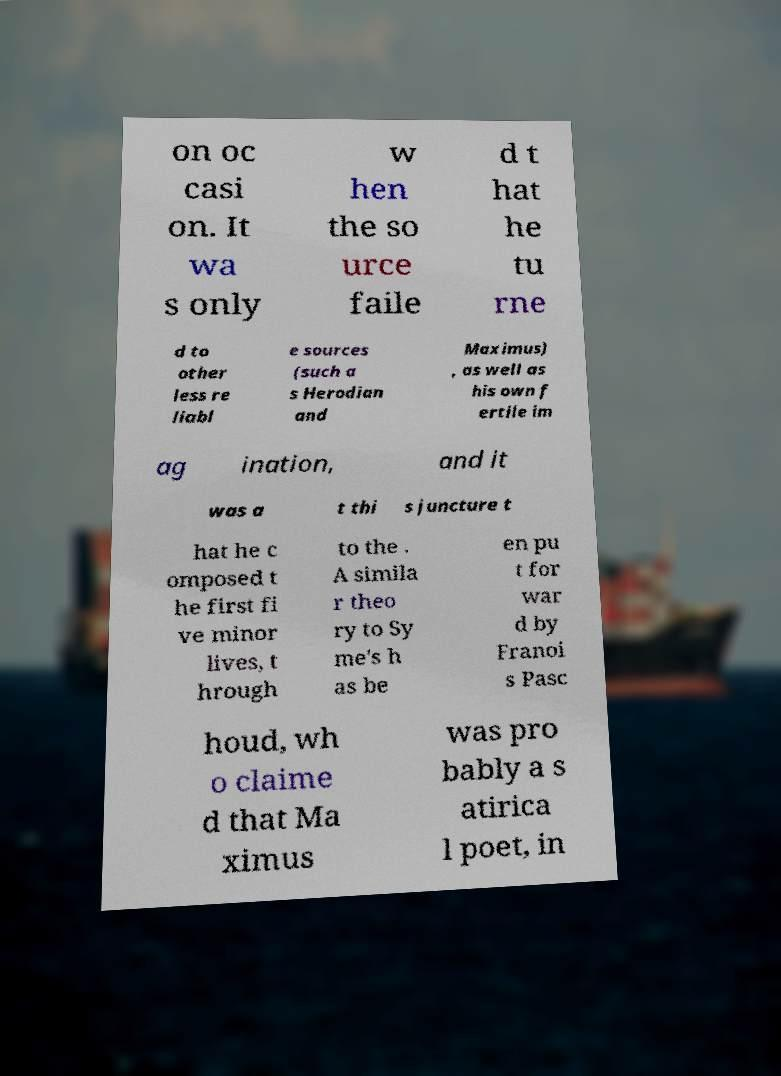Please identify and transcribe the text found in this image. on oc casi on. It wa s only w hen the so urce faile d t hat he tu rne d to other less re liabl e sources (such a s Herodian and Maximus) , as well as his own f ertile im ag ination, and it was a t thi s juncture t hat he c omposed t he first fi ve minor lives, t hrough to the . A simila r theo ry to Sy me's h as be en pu t for war d by Franoi s Pasc houd, wh o claime d that Ma ximus was pro bably a s atirica l poet, in 